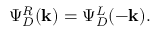<formula> <loc_0><loc_0><loc_500><loc_500>\Psi _ { D } ^ { R } ( k ) = \Psi _ { D } ^ { L } ( - k ) .</formula> 